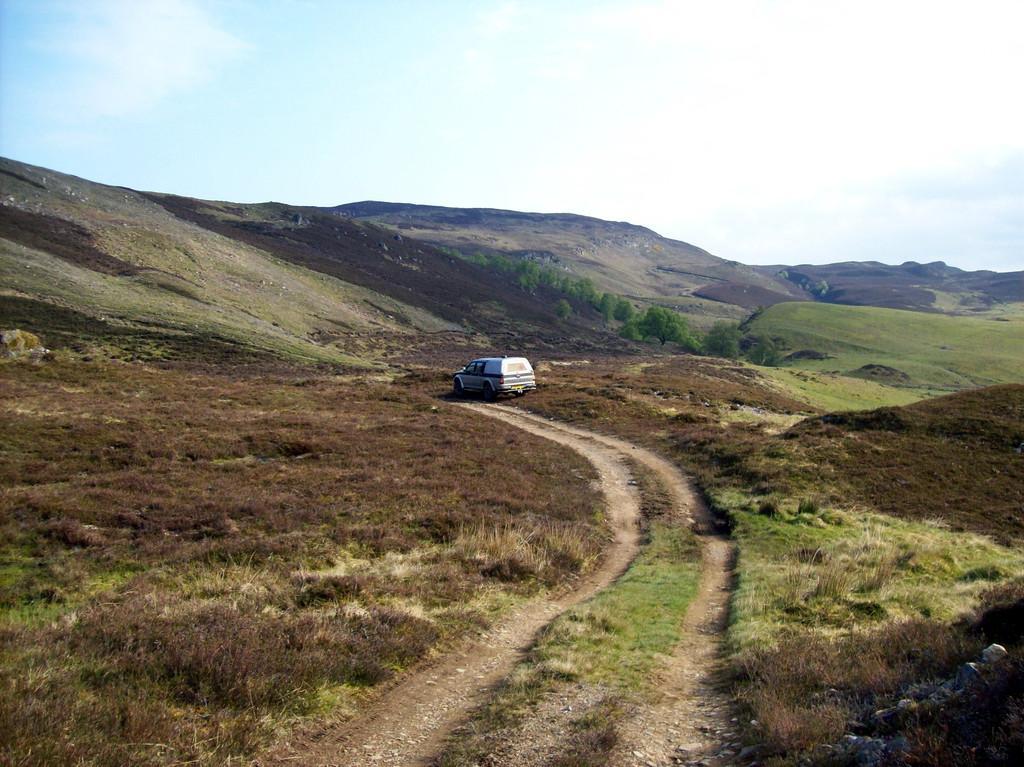Please provide a concise description of this image. In this image we can see the vehicle, grass, dried grass, stones, trees, hills, at the top we can see the sky. 